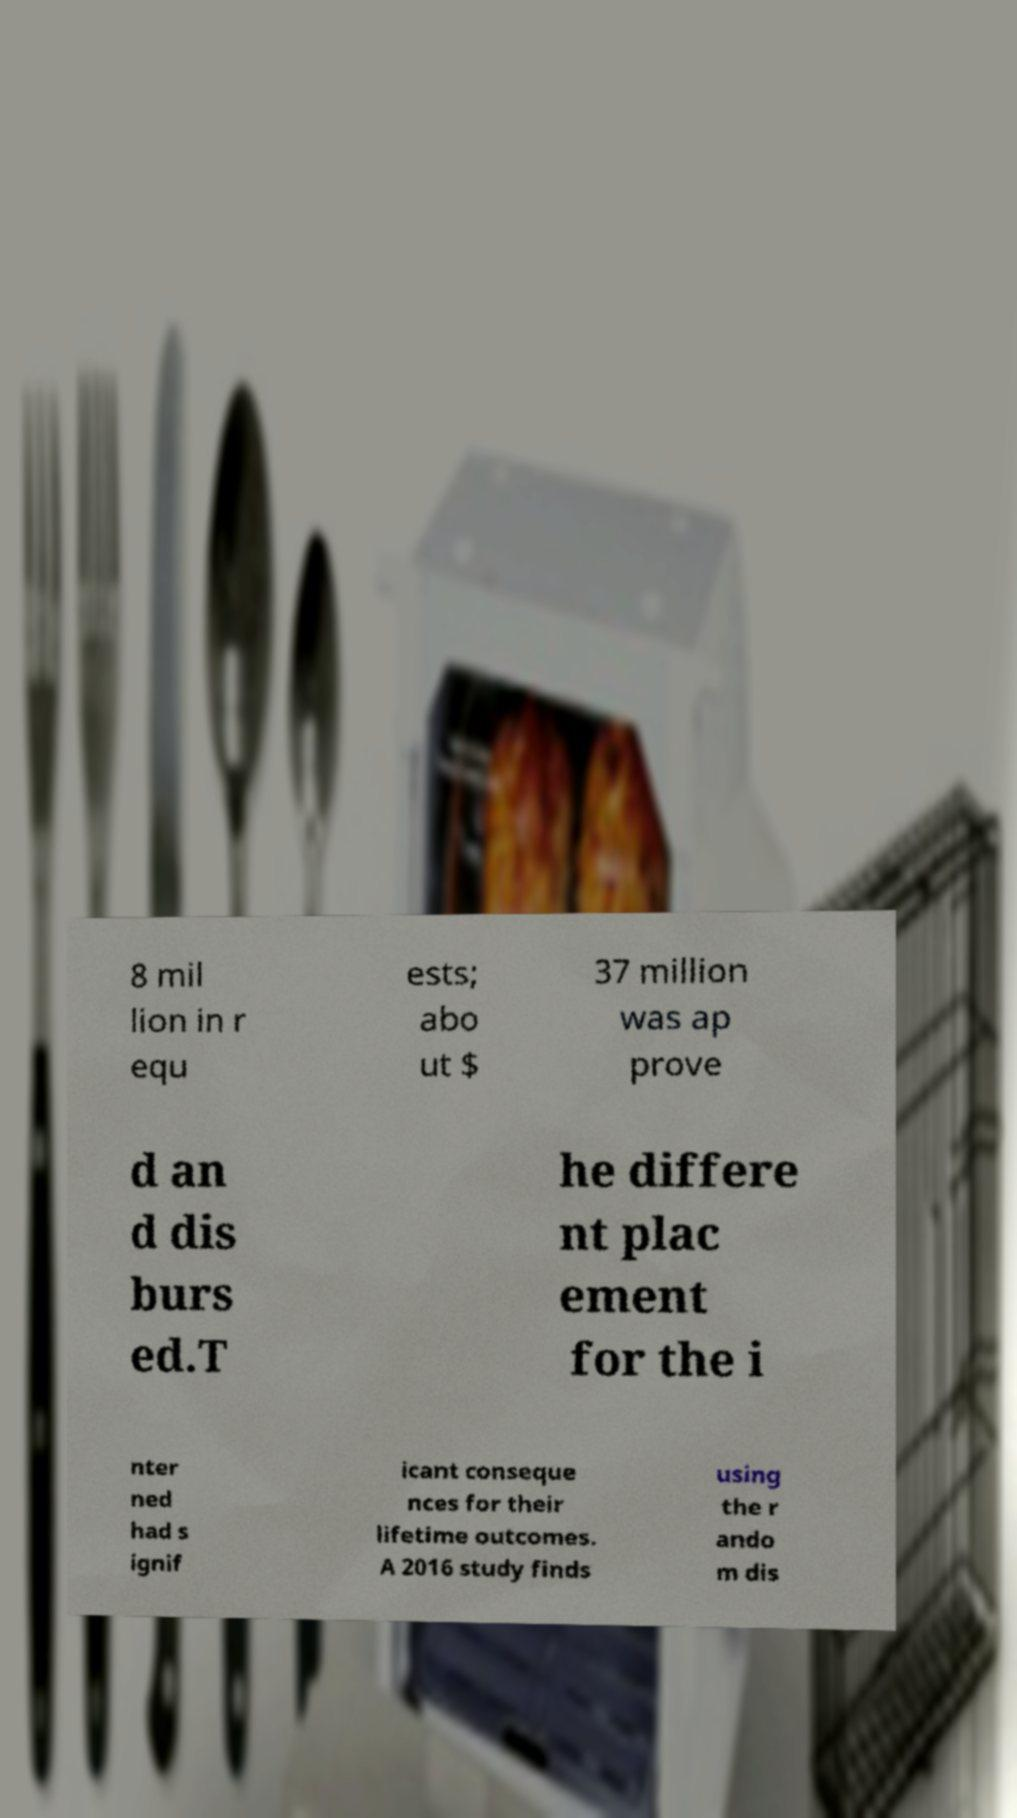Can you read and provide the text displayed in the image?This photo seems to have some interesting text. Can you extract and type it out for me? 8 mil lion in r equ ests; abo ut $ 37 million was ap prove d an d dis burs ed.T he differe nt plac ement for the i nter ned had s ignif icant conseque nces for their lifetime outcomes. A 2016 study finds using the r ando m dis 